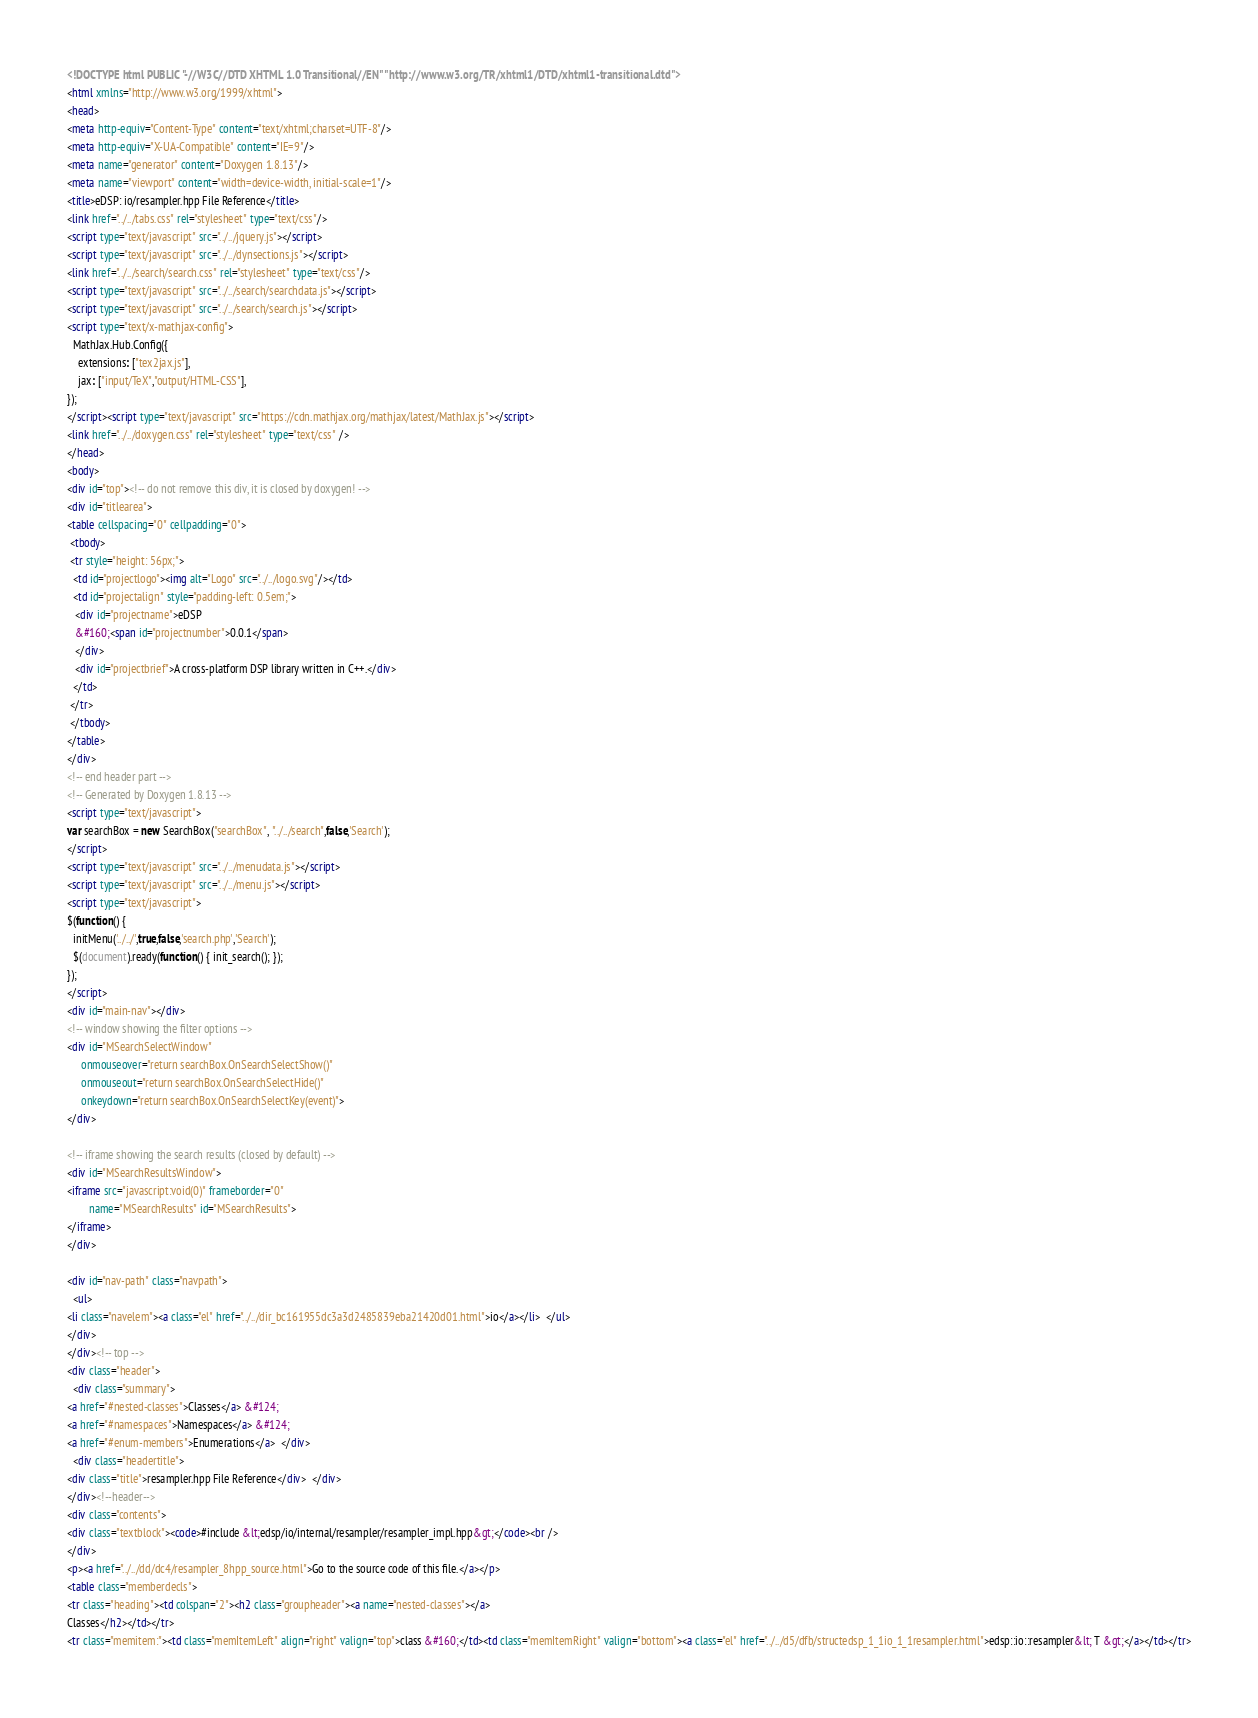Convert code to text. <code><loc_0><loc_0><loc_500><loc_500><_HTML_><!DOCTYPE html PUBLIC "-//W3C//DTD XHTML 1.0 Transitional//EN" "http://www.w3.org/TR/xhtml1/DTD/xhtml1-transitional.dtd">
<html xmlns="http://www.w3.org/1999/xhtml">
<head>
<meta http-equiv="Content-Type" content="text/xhtml;charset=UTF-8"/>
<meta http-equiv="X-UA-Compatible" content="IE=9"/>
<meta name="generator" content="Doxygen 1.8.13"/>
<meta name="viewport" content="width=device-width, initial-scale=1"/>
<title>eDSP: io/resampler.hpp File Reference</title>
<link href="../../tabs.css" rel="stylesheet" type="text/css"/>
<script type="text/javascript" src="../../jquery.js"></script>
<script type="text/javascript" src="../../dynsections.js"></script>
<link href="../../search/search.css" rel="stylesheet" type="text/css"/>
<script type="text/javascript" src="../../search/searchdata.js"></script>
<script type="text/javascript" src="../../search/search.js"></script>
<script type="text/x-mathjax-config">
  MathJax.Hub.Config({
    extensions: ["tex2jax.js"],
    jax: ["input/TeX","output/HTML-CSS"],
});
</script><script type="text/javascript" src="https://cdn.mathjax.org/mathjax/latest/MathJax.js"></script>
<link href="../../doxygen.css" rel="stylesheet" type="text/css" />
</head>
<body>
<div id="top"><!-- do not remove this div, it is closed by doxygen! -->
<div id="titlearea">
<table cellspacing="0" cellpadding="0">
 <tbody>
 <tr style="height: 56px;">
  <td id="projectlogo"><img alt="Logo" src="../../logo.svg"/></td>
  <td id="projectalign" style="padding-left: 0.5em;">
   <div id="projectname">eDSP
   &#160;<span id="projectnumber">0.0.1</span>
   </div>
   <div id="projectbrief">A cross-platform DSP library written in C++.</div>
  </td>
 </tr>
 </tbody>
</table>
</div>
<!-- end header part -->
<!-- Generated by Doxygen 1.8.13 -->
<script type="text/javascript">
var searchBox = new SearchBox("searchBox", "../../search",false,'Search');
</script>
<script type="text/javascript" src="../../menudata.js"></script>
<script type="text/javascript" src="../../menu.js"></script>
<script type="text/javascript">
$(function() {
  initMenu('../../',true,false,'search.php','Search');
  $(document).ready(function() { init_search(); });
});
</script>
<div id="main-nav"></div>
<!-- window showing the filter options -->
<div id="MSearchSelectWindow"
     onmouseover="return searchBox.OnSearchSelectShow()"
     onmouseout="return searchBox.OnSearchSelectHide()"
     onkeydown="return searchBox.OnSearchSelectKey(event)">
</div>

<!-- iframe showing the search results (closed by default) -->
<div id="MSearchResultsWindow">
<iframe src="javascript:void(0)" frameborder="0" 
        name="MSearchResults" id="MSearchResults">
</iframe>
</div>

<div id="nav-path" class="navpath">
  <ul>
<li class="navelem"><a class="el" href="../../dir_bc161955dc3a3d2485839eba21420d01.html">io</a></li>  </ul>
</div>
</div><!-- top -->
<div class="header">
  <div class="summary">
<a href="#nested-classes">Classes</a> &#124;
<a href="#namespaces">Namespaces</a> &#124;
<a href="#enum-members">Enumerations</a>  </div>
  <div class="headertitle">
<div class="title">resampler.hpp File Reference</div>  </div>
</div><!--header-->
<div class="contents">
<div class="textblock"><code>#include &lt;edsp/io/internal/resampler/resampler_impl.hpp&gt;</code><br />
</div>
<p><a href="../../dd/dc4/resampler_8hpp_source.html">Go to the source code of this file.</a></p>
<table class="memberdecls">
<tr class="heading"><td colspan="2"><h2 class="groupheader"><a name="nested-classes"></a>
Classes</h2></td></tr>
<tr class="memitem:"><td class="memItemLeft" align="right" valign="top">class &#160;</td><td class="memItemRight" valign="bottom"><a class="el" href="../../d5/dfb/structedsp_1_1io_1_1resampler.html">edsp::io::resampler&lt; T &gt;</a></td></tr></code> 